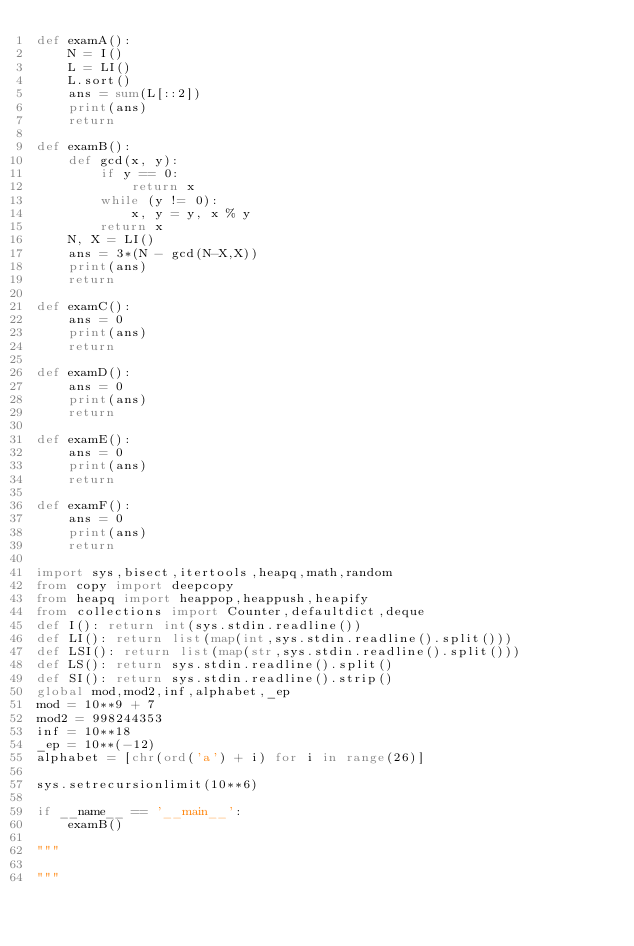<code> <loc_0><loc_0><loc_500><loc_500><_Python_>def examA():
    N = I()
    L = LI()
    L.sort()
    ans = sum(L[::2])
    print(ans)
    return

def examB():
    def gcd(x, y):
        if y == 0:
            return x
        while (y != 0):
            x, y = y, x % y
        return x
    N, X = LI()
    ans = 3*(N - gcd(N-X,X))
    print(ans)
    return

def examC():
    ans = 0
    print(ans)
    return

def examD():
    ans = 0
    print(ans)
    return

def examE():
    ans = 0
    print(ans)
    return

def examF():
    ans = 0
    print(ans)
    return

import sys,bisect,itertools,heapq,math,random
from copy import deepcopy
from heapq import heappop,heappush,heapify
from collections import Counter,defaultdict,deque
def I(): return int(sys.stdin.readline())
def LI(): return list(map(int,sys.stdin.readline().split()))
def LSI(): return list(map(str,sys.stdin.readline().split()))
def LS(): return sys.stdin.readline().split()
def SI(): return sys.stdin.readline().strip()
global mod,mod2,inf,alphabet,_ep
mod = 10**9 + 7
mod2 = 998244353
inf = 10**18
_ep = 10**(-12)
alphabet = [chr(ord('a') + i) for i in range(26)]

sys.setrecursionlimit(10**6)

if __name__ == '__main__':
    examB()

"""

"""</code> 